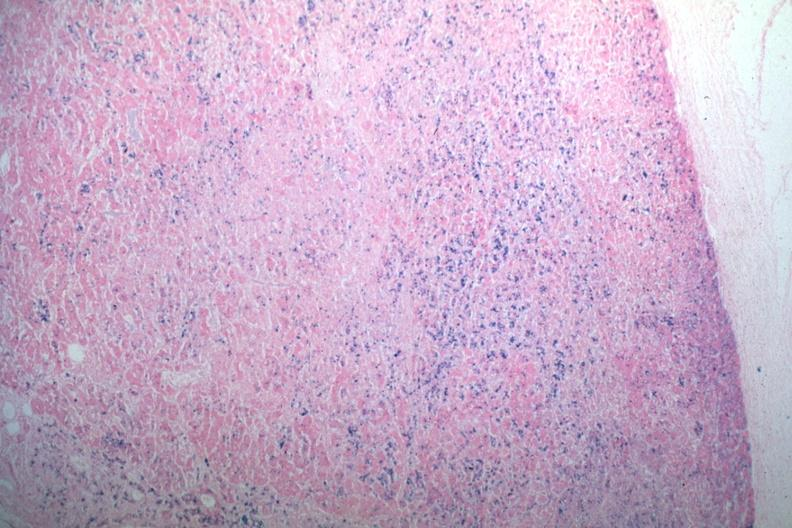what is present?
Answer the question using a single word or phrase. Pituitary 